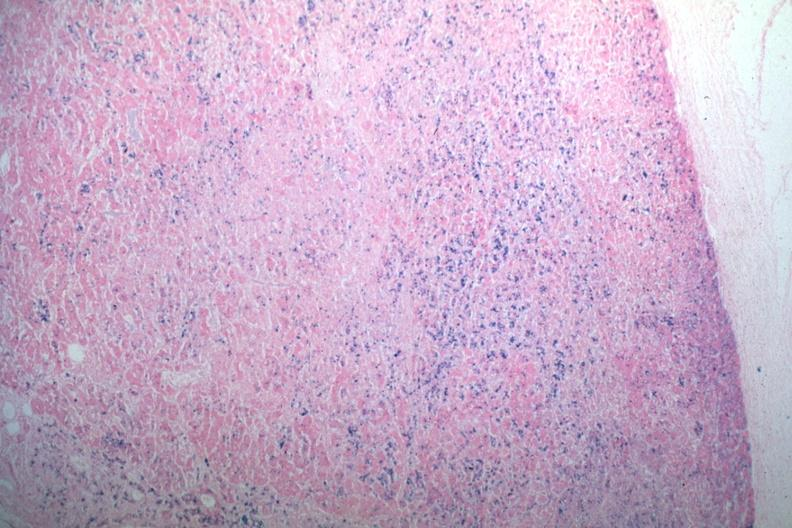what is present?
Answer the question using a single word or phrase. Pituitary 